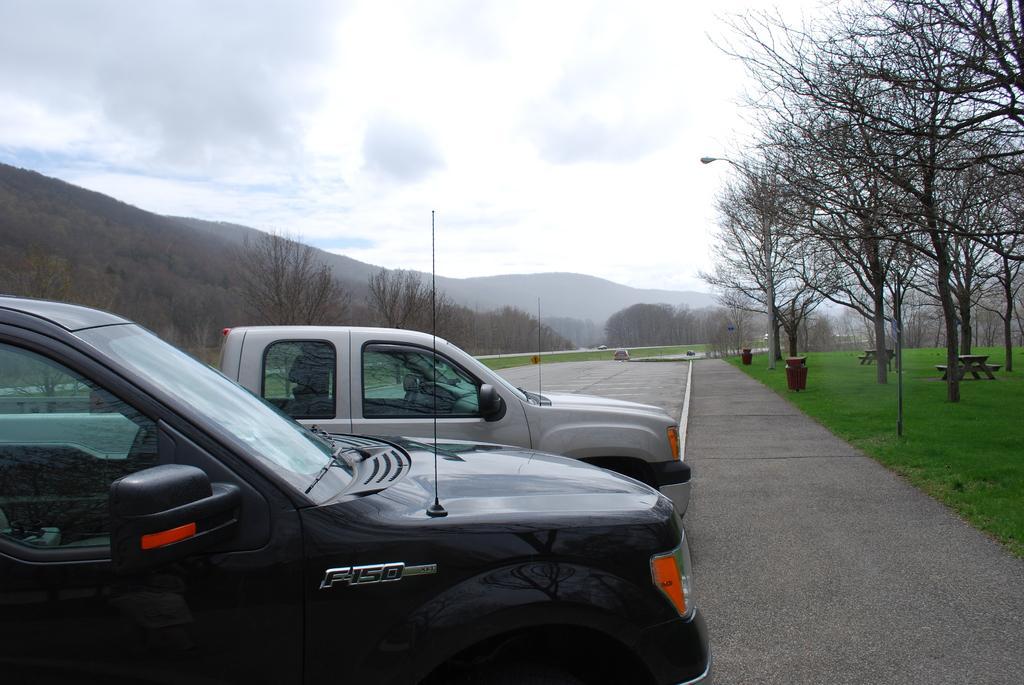Can you describe this image briefly? In this image we can see two cars on the road. On the right side of the image, we can see trees, grassy land and benches. In the background, we can see dry trees and mountains. At the top of the image, we can see the sky covered with clouds. 